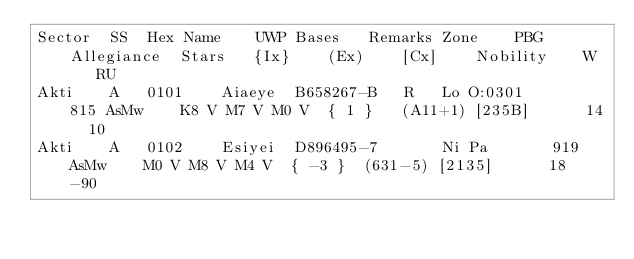<code> <loc_0><loc_0><loc_500><loc_500><_SQL_>Sector	SS	Hex	Name	UWP	Bases	Remarks	Zone	PBG	Allegiance	Stars	{Ix}	(Ex)	[Cx]	Nobility	W	RU
Akti	A	0101	Aiaeye	B658267-B	R	Lo O:0301		815	AsMw	K8 V M7 V M0 V	{ 1 }	(A11+1)	[235B]		14	10
Akti	A	0102	Esiyei	D896495-7		Ni Pa		919	AsMw	M0 V M8 V M4 V	{ -3 }	(631-5)	[2135]		18	-90</code> 